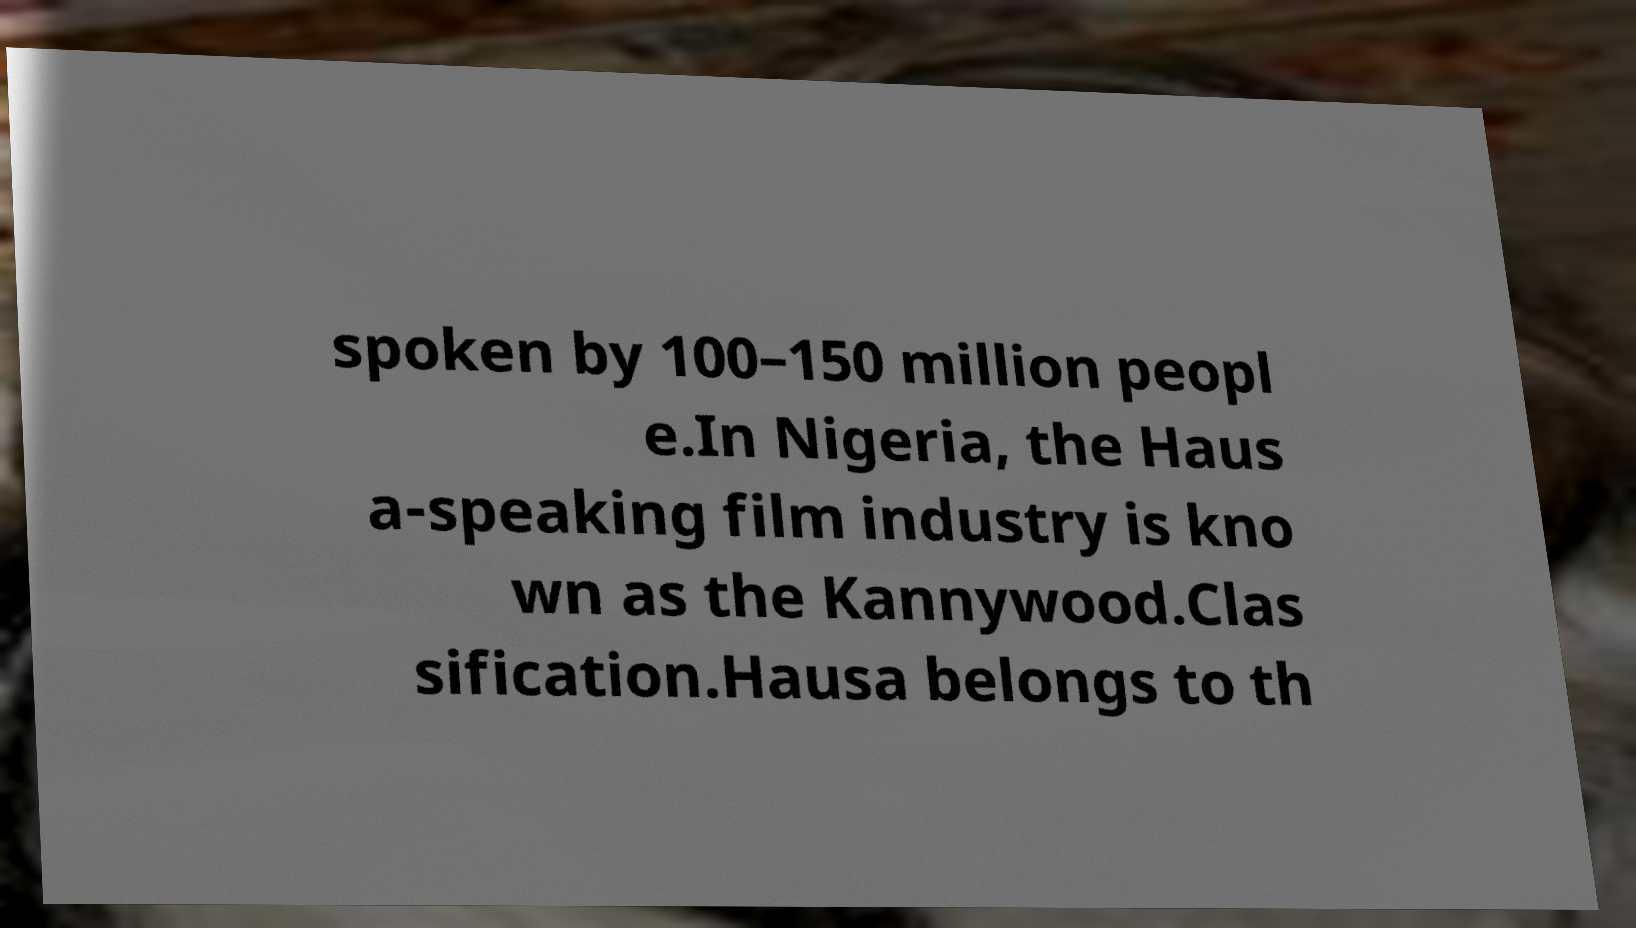Can you accurately transcribe the text from the provided image for me? spoken by 100–150 million peopl e.In Nigeria, the Haus a-speaking film industry is kno wn as the Kannywood.Clas sification.Hausa belongs to th 